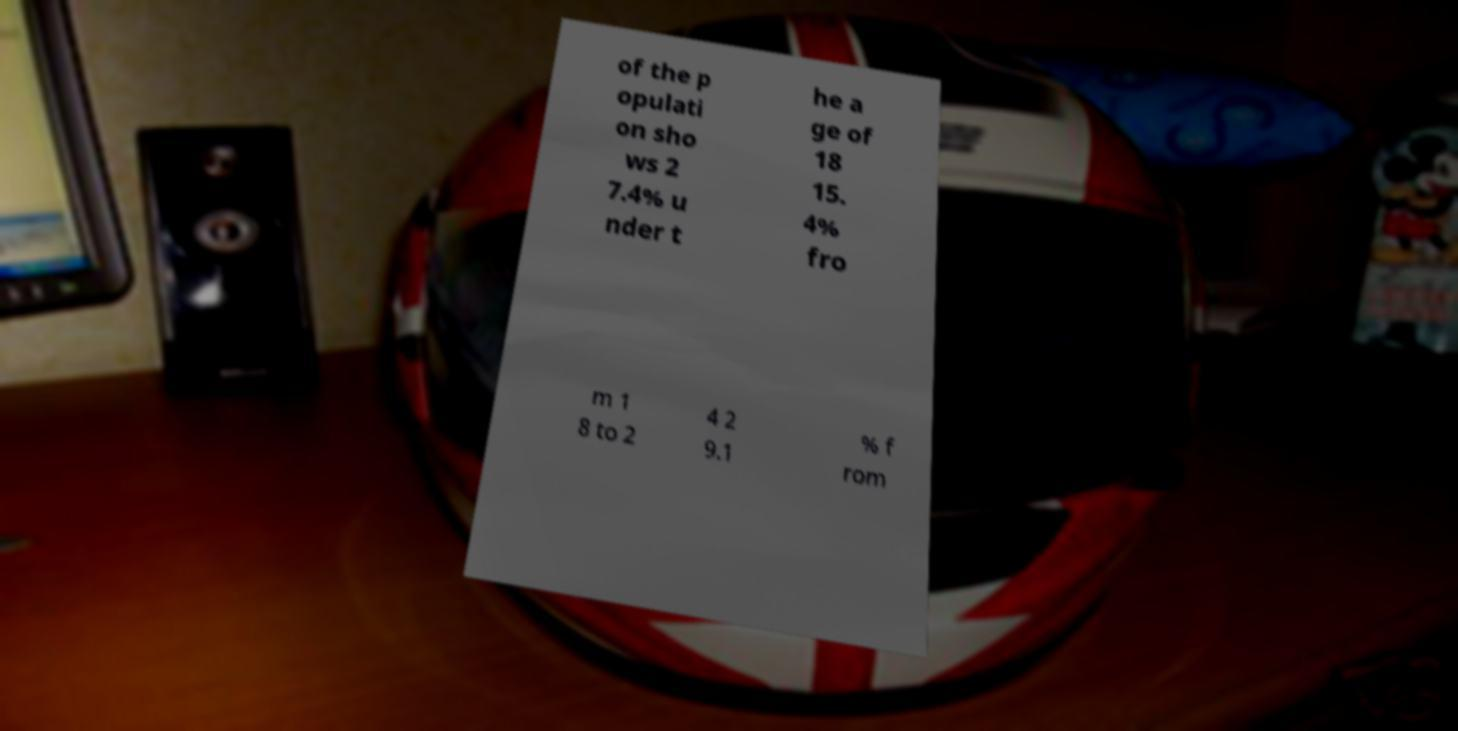Please read and relay the text visible in this image. What does it say? of the p opulati on sho ws 2 7.4% u nder t he a ge of 18 15. 4% fro m 1 8 to 2 4 2 9.1 % f rom 